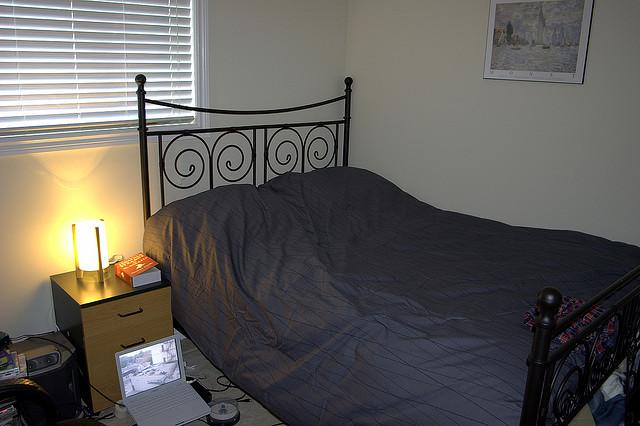Is the light off?
Answer briefly. No. Where is the laptop?
Concise answer only. Floor. Is this a hotel room?
Answer briefly. No. Is the laptop on?
Concise answer only. Yes. 